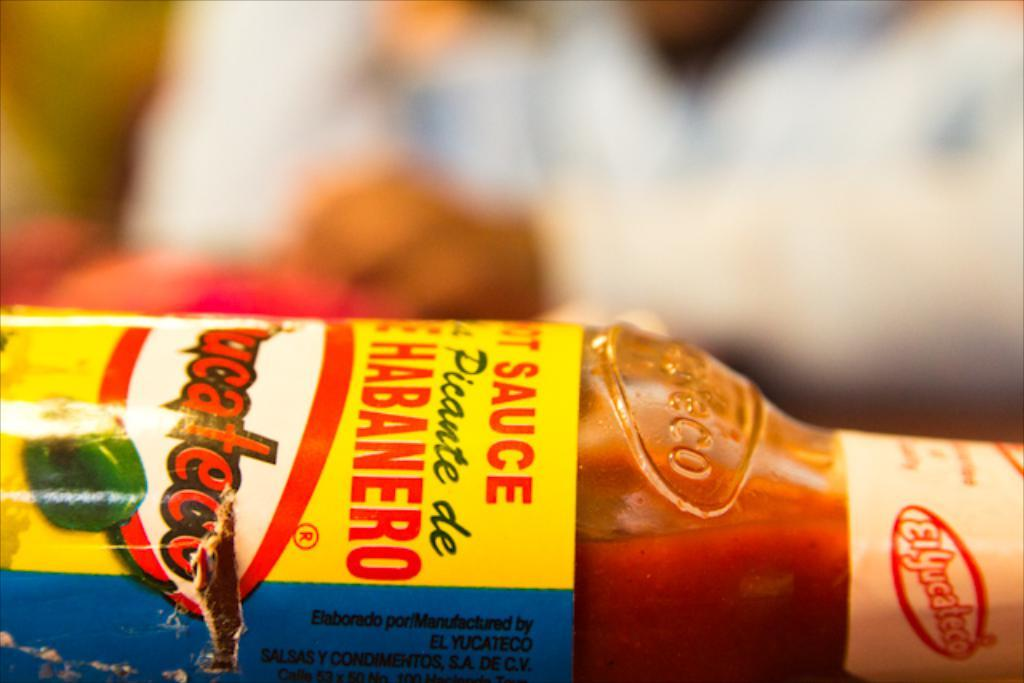<image>
Present a compact description of the photo's key features. A bottle of El Yucateco's Habanero hot sauce 